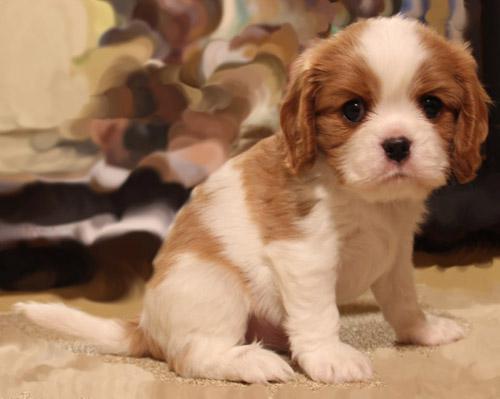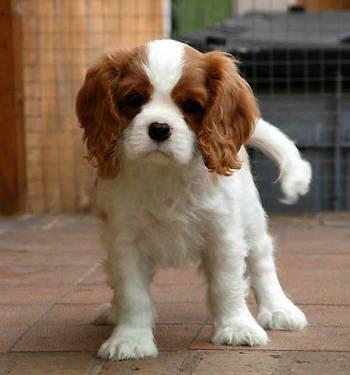The first image is the image on the left, the second image is the image on the right. Analyze the images presented: Is the assertion "There is exactly one animal sitting in the image on the left." valid? Answer yes or no. Yes. 